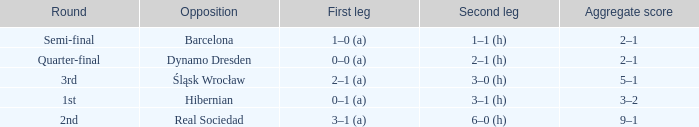What was the first leg score against Real Sociedad? 3–1 (a). 